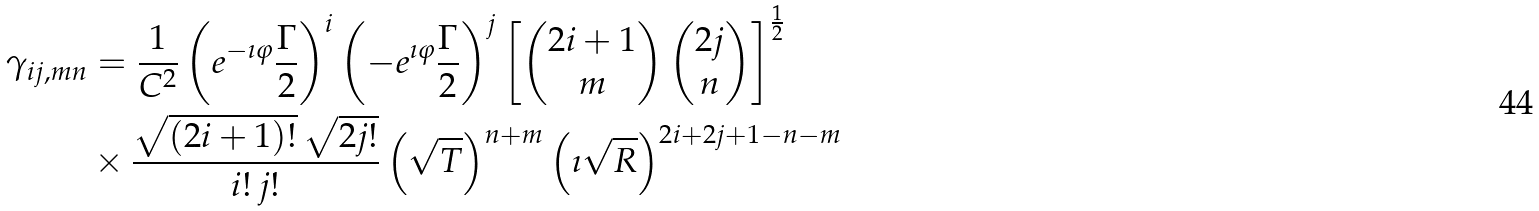<formula> <loc_0><loc_0><loc_500><loc_500>\gamma _ { i j , m n } & = \frac { 1 } { C ^ { 2 } } \left ( e ^ { - \imath \varphi } \frac { \Gamma } { 2 } \right ) ^ { i } \left ( - e ^ { \imath \varphi } \frac { \Gamma } { 2 } \right ) ^ { j } \left [ \begin{pmatrix} 2 i + 1 \\ m \end{pmatrix} \begin{pmatrix} 2 j \\ n \end{pmatrix} \right ] ^ { \frac { 1 } { 2 } } \\ & \times \frac { \sqrt { ( 2 i + 1 ) ! } \, \sqrt { 2 j ! } } { i ! \, j ! } \left ( \sqrt { T } \right ) ^ { n + m } \left ( \imath \sqrt { R } \right ) ^ { 2 i + 2 j + 1 - n - m }</formula> 